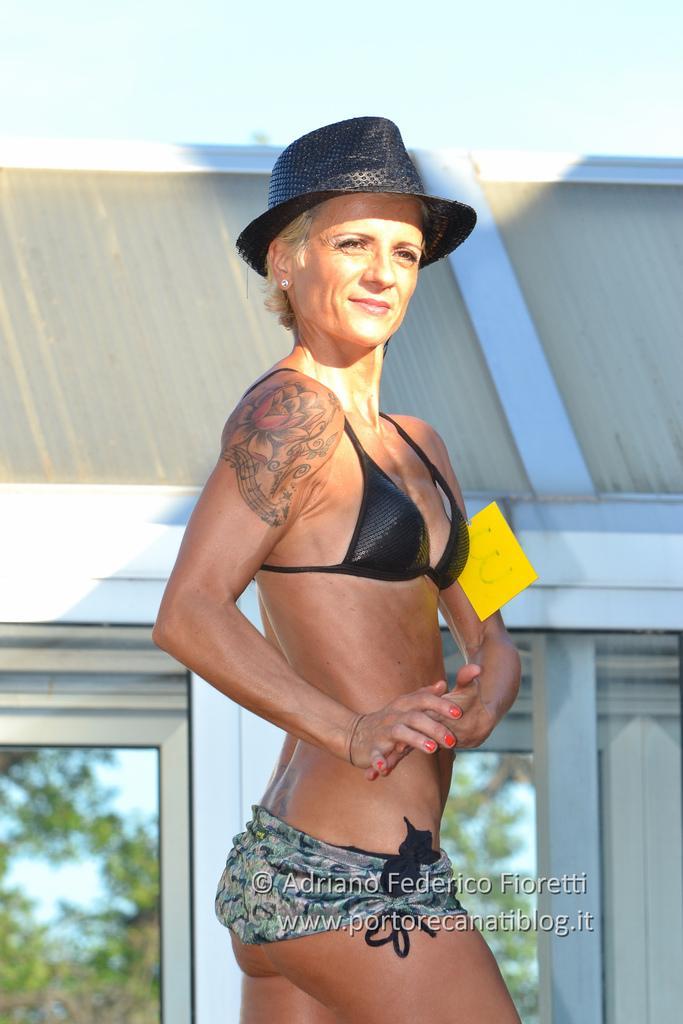Describe this image in one or two sentences. In this image I can see a woman is standing and I can see she is wearing a black hat. I can also see a yellow colour thing over here and in the background I can see a building. 